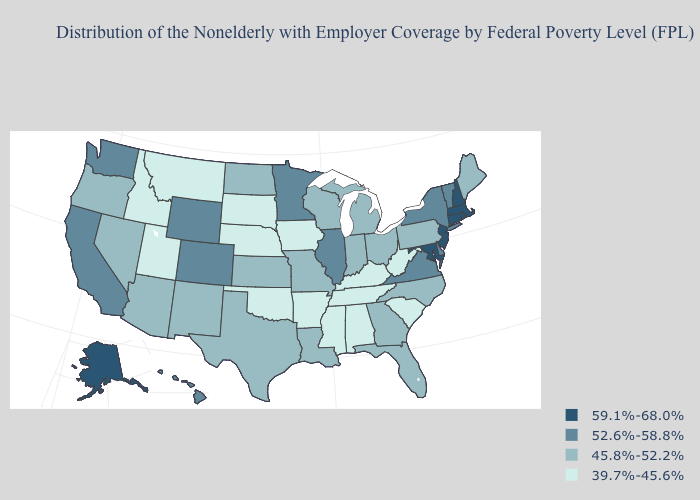Which states have the lowest value in the MidWest?
Short answer required. Iowa, Nebraska, South Dakota. Among the states that border Maine , which have the highest value?
Answer briefly. New Hampshire. Does Arkansas have the highest value in the South?
Be succinct. No. Name the states that have a value in the range 45.8%-52.2%?
Write a very short answer. Arizona, Florida, Georgia, Indiana, Kansas, Louisiana, Maine, Michigan, Missouri, Nevada, New Mexico, North Carolina, North Dakota, Ohio, Oregon, Pennsylvania, Texas, Wisconsin. What is the value of Arkansas?
Concise answer only. 39.7%-45.6%. Does the map have missing data?
Be succinct. No. How many symbols are there in the legend?
Short answer required. 4. Is the legend a continuous bar?
Write a very short answer. No. Is the legend a continuous bar?
Give a very brief answer. No. What is the highest value in the USA?
Answer briefly. 59.1%-68.0%. Name the states that have a value in the range 39.7%-45.6%?
Be succinct. Alabama, Arkansas, Idaho, Iowa, Kentucky, Mississippi, Montana, Nebraska, Oklahoma, South Carolina, South Dakota, Tennessee, Utah, West Virginia. What is the value of Michigan?
Be succinct. 45.8%-52.2%. Does Louisiana have a higher value than California?
Give a very brief answer. No. Does New Jersey have the highest value in the Northeast?
Give a very brief answer. Yes. What is the lowest value in the USA?
Quick response, please. 39.7%-45.6%. 